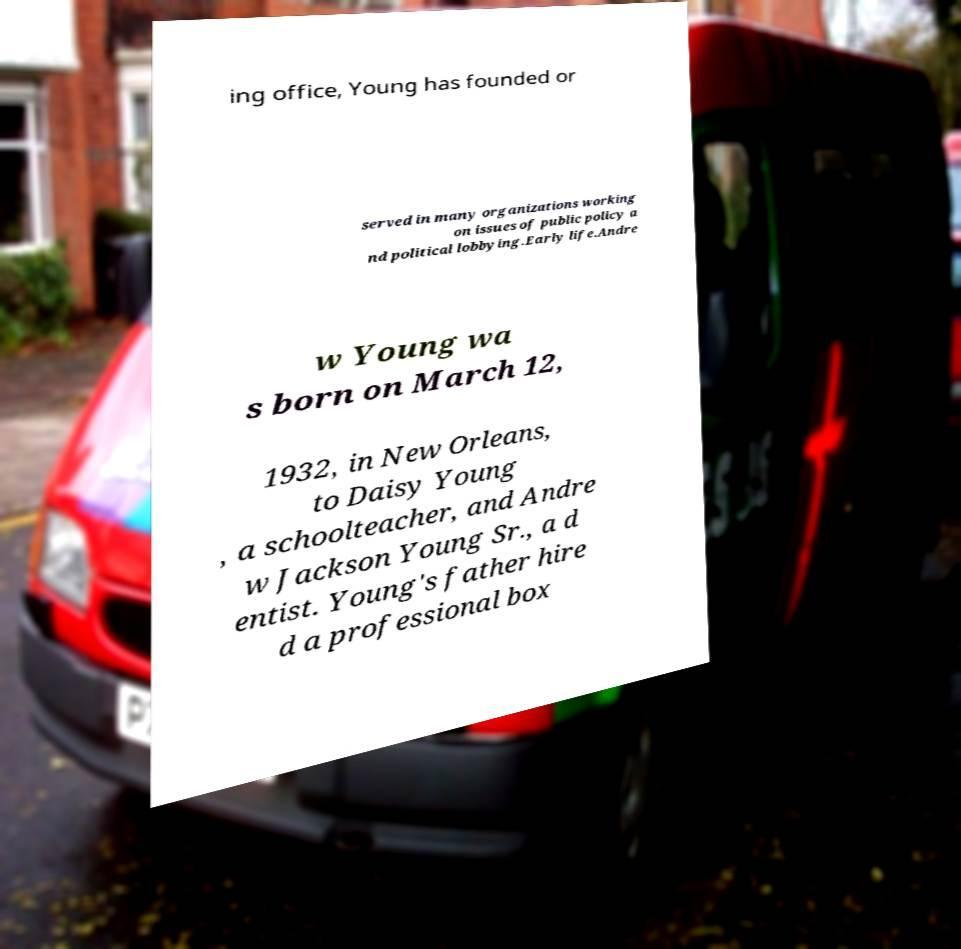What messages or text are displayed in this image? I need them in a readable, typed format. ing office, Young has founded or served in many organizations working on issues of public policy a nd political lobbying.Early life.Andre w Young wa s born on March 12, 1932, in New Orleans, to Daisy Young , a schoolteacher, and Andre w Jackson Young Sr., a d entist. Young's father hire d a professional box 